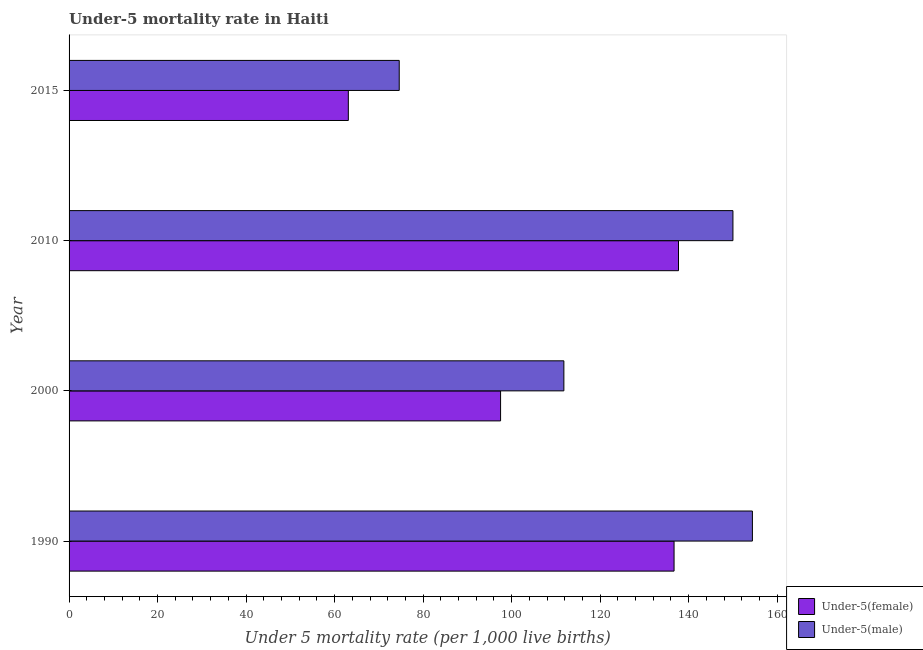How many different coloured bars are there?
Provide a short and direct response. 2. Are the number of bars per tick equal to the number of legend labels?
Make the answer very short. Yes. How many bars are there on the 3rd tick from the top?
Offer a terse response. 2. How many bars are there on the 3rd tick from the bottom?
Make the answer very short. 2. What is the label of the 1st group of bars from the top?
Offer a very short reply. 2015. In how many cases, is the number of bars for a given year not equal to the number of legend labels?
Provide a succinct answer. 0. What is the under-5 male mortality rate in 2010?
Provide a succinct answer. 150. Across all years, what is the maximum under-5 male mortality rate?
Make the answer very short. 154.4. Across all years, what is the minimum under-5 male mortality rate?
Give a very brief answer. 74.6. In which year was the under-5 female mortality rate minimum?
Offer a terse response. 2015. What is the total under-5 male mortality rate in the graph?
Provide a succinct answer. 490.8. What is the difference between the under-5 female mortality rate in 1990 and that in 2000?
Provide a succinct answer. 39.2. What is the difference between the under-5 male mortality rate in 2010 and the under-5 female mortality rate in 2015?
Keep it short and to the point. 86.9. What is the average under-5 male mortality rate per year?
Ensure brevity in your answer.  122.7. In the year 2000, what is the difference between the under-5 female mortality rate and under-5 male mortality rate?
Offer a terse response. -14.3. In how many years, is the under-5 male mortality rate greater than 100 ?
Your response must be concise. 3. What is the difference between the highest and the second highest under-5 male mortality rate?
Ensure brevity in your answer.  4.4. What is the difference between the highest and the lowest under-5 male mortality rate?
Your response must be concise. 79.8. In how many years, is the under-5 female mortality rate greater than the average under-5 female mortality rate taken over all years?
Your response must be concise. 2. What does the 2nd bar from the top in 2015 represents?
Keep it short and to the point. Under-5(female). What does the 1st bar from the bottom in 2000 represents?
Keep it short and to the point. Under-5(female). How many bars are there?
Offer a very short reply. 8. Does the graph contain any zero values?
Your response must be concise. No. Does the graph contain grids?
Give a very brief answer. No. Where does the legend appear in the graph?
Make the answer very short. Bottom right. How are the legend labels stacked?
Keep it short and to the point. Vertical. What is the title of the graph?
Offer a very short reply. Under-5 mortality rate in Haiti. Does "Goods" appear as one of the legend labels in the graph?
Offer a terse response. No. What is the label or title of the X-axis?
Provide a short and direct response. Under 5 mortality rate (per 1,0 live births). What is the label or title of the Y-axis?
Make the answer very short. Year. What is the Under 5 mortality rate (per 1,000 live births) of Under-5(female) in 1990?
Offer a very short reply. 136.7. What is the Under 5 mortality rate (per 1,000 live births) in Under-5(male) in 1990?
Offer a terse response. 154.4. What is the Under 5 mortality rate (per 1,000 live births) of Under-5(female) in 2000?
Offer a very short reply. 97.5. What is the Under 5 mortality rate (per 1,000 live births) of Under-5(male) in 2000?
Offer a terse response. 111.8. What is the Under 5 mortality rate (per 1,000 live births) in Under-5(female) in 2010?
Give a very brief answer. 137.7. What is the Under 5 mortality rate (per 1,000 live births) in Under-5(male) in 2010?
Offer a very short reply. 150. What is the Under 5 mortality rate (per 1,000 live births) of Under-5(female) in 2015?
Your response must be concise. 63.1. What is the Under 5 mortality rate (per 1,000 live births) of Under-5(male) in 2015?
Provide a succinct answer. 74.6. Across all years, what is the maximum Under 5 mortality rate (per 1,000 live births) of Under-5(female)?
Provide a succinct answer. 137.7. Across all years, what is the maximum Under 5 mortality rate (per 1,000 live births) of Under-5(male)?
Offer a very short reply. 154.4. Across all years, what is the minimum Under 5 mortality rate (per 1,000 live births) of Under-5(female)?
Ensure brevity in your answer.  63.1. Across all years, what is the minimum Under 5 mortality rate (per 1,000 live births) of Under-5(male)?
Make the answer very short. 74.6. What is the total Under 5 mortality rate (per 1,000 live births) of Under-5(female) in the graph?
Provide a short and direct response. 435. What is the total Under 5 mortality rate (per 1,000 live births) in Under-5(male) in the graph?
Keep it short and to the point. 490.8. What is the difference between the Under 5 mortality rate (per 1,000 live births) of Under-5(female) in 1990 and that in 2000?
Your answer should be very brief. 39.2. What is the difference between the Under 5 mortality rate (per 1,000 live births) of Under-5(male) in 1990 and that in 2000?
Your answer should be compact. 42.6. What is the difference between the Under 5 mortality rate (per 1,000 live births) in Under-5(female) in 1990 and that in 2010?
Offer a terse response. -1. What is the difference between the Under 5 mortality rate (per 1,000 live births) in Under-5(male) in 1990 and that in 2010?
Your response must be concise. 4.4. What is the difference between the Under 5 mortality rate (per 1,000 live births) of Under-5(female) in 1990 and that in 2015?
Ensure brevity in your answer.  73.6. What is the difference between the Under 5 mortality rate (per 1,000 live births) in Under-5(male) in 1990 and that in 2015?
Offer a terse response. 79.8. What is the difference between the Under 5 mortality rate (per 1,000 live births) of Under-5(female) in 2000 and that in 2010?
Ensure brevity in your answer.  -40.2. What is the difference between the Under 5 mortality rate (per 1,000 live births) in Under-5(male) in 2000 and that in 2010?
Your answer should be very brief. -38.2. What is the difference between the Under 5 mortality rate (per 1,000 live births) of Under-5(female) in 2000 and that in 2015?
Give a very brief answer. 34.4. What is the difference between the Under 5 mortality rate (per 1,000 live births) in Under-5(male) in 2000 and that in 2015?
Offer a very short reply. 37.2. What is the difference between the Under 5 mortality rate (per 1,000 live births) of Under-5(female) in 2010 and that in 2015?
Your answer should be very brief. 74.6. What is the difference between the Under 5 mortality rate (per 1,000 live births) of Under-5(male) in 2010 and that in 2015?
Ensure brevity in your answer.  75.4. What is the difference between the Under 5 mortality rate (per 1,000 live births) of Under-5(female) in 1990 and the Under 5 mortality rate (per 1,000 live births) of Under-5(male) in 2000?
Keep it short and to the point. 24.9. What is the difference between the Under 5 mortality rate (per 1,000 live births) in Under-5(female) in 1990 and the Under 5 mortality rate (per 1,000 live births) in Under-5(male) in 2010?
Make the answer very short. -13.3. What is the difference between the Under 5 mortality rate (per 1,000 live births) in Under-5(female) in 1990 and the Under 5 mortality rate (per 1,000 live births) in Under-5(male) in 2015?
Provide a short and direct response. 62.1. What is the difference between the Under 5 mortality rate (per 1,000 live births) of Under-5(female) in 2000 and the Under 5 mortality rate (per 1,000 live births) of Under-5(male) in 2010?
Provide a succinct answer. -52.5. What is the difference between the Under 5 mortality rate (per 1,000 live births) of Under-5(female) in 2000 and the Under 5 mortality rate (per 1,000 live births) of Under-5(male) in 2015?
Keep it short and to the point. 22.9. What is the difference between the Under 5 mortality rate (per 1,000 live births) in Under-5(female) in 2010 and the Under 5 mortality rate (per 1,000 live births) in Under-5(male) in 2015?
Make the answer very short. 63.1. What is the average Under 5 mortality rate (per 1,000 live births) in Under-5(female) per year?
Your answer should be very brief. 108.75. What is the average Under 5 mortality rate (per 1,000 live births) in Under-5(male) per year?
Make the answer very short. 122.7. In the year 1990, what is the difference between the Under 5 mortality rate (per 1,000 live births) in Under-5(female) and Under 5 mortality rate (per 1,000 live births) in Under-5(male)?
Make the answer very short. -17.7. In the year 2000, what is the difference between the Under 5 mortality rate (per 1,000 live births) of Under-5(female) and Under 5 mortality rate (per 1,000 live births) of Under-5(male)?
Provide a short and direct response. -14.3. In the year 2010, what is the difference between the Under 5 mortality rate (per 1,000 live births) of Under-5(female) and Under 5 mortality rate (per 1,000 live births) of Under-5(male)?
Your answer should be very brief. -12.3. What is the ratio of the Under 5 mortality rate (per 1,000 live births) in Under-5(female) in 1990 to that in 2000?
Make the answer very short. 1.4. What is the ratio of the Under 5 mortality rate (per 1,000 live births) in Under-5(male) in 1990 to that in 2000?
Offer a terse response. 1.38. What is the ratio of the Under 5 mortality rate (per 1,000 live births) of Under-5(male) in 1990 to that in 2010?
Your response must be concise. 1.03. What is the ratio of the Under 5 mortality rate (per 1,000 live births) of Under-5(female) in 1990 to that in 2015?
Offer a terse response. 2.17. What is the ratio of the Under 5 mortality rate (per 1,000 live births) of Under-5(male) in 1990 to that in 2015?
Ensure brevity in your answer.  2.07. What is the ratio of the Under 5 mortality rate (per 1,000 live births) of Under-5(female) in 2000 to that in 2010?
Provide a short and direct response. 0.71. What is the ratio of the Under 5 mortality rate (per 1,000 live births) of Under-5(male) in 2000 to that in 2010?
Keep it short and to the point. 0.75. What is the ratio of the Under 5 mortality rate (per 1,000 live births) of Under-5(female) in 2000 to that in 2015?
Make the answer very short. 1.55. What is the ratio of the Under 5 mortality rate (per 1,000 live births) in Under-5(male) in 2000 to that in 2015?
Offer a very short reply. 1.5. What is the ratio of the Under 5 mortality rate (per 1,000 live births) in Under-5(female) in 2010 to that in 2015?
Ensure brevity in your answer.  2.18. What is the ratio of the Under 5 mortality rate (per 1,000 live births) of Under-5(male) in 2010 to that in 2015?
Your answer should be compact. 2.01. What is the difference between the highest and the second highest Under 5 mortality rate (per 1,000 live births) of Under-5(female)?
Ensure brevity in your answer.  1. What is the difference between the highest and the second highest Under 5 mortality rate (per 1,000 live births) in Under-5(male)?
Give a very brief answer. 4.4. What is the difference between the highest and the lowest Under 5 mortality rate (per 1,000 live births) of Under-5(female)?
Offer a very short reply. 74.6. What is the difference between the highest and the lowest Under 5 mortality rate (per 1,000 live births) of Under-5(male)?
Give a very brief answer. 79.8. 